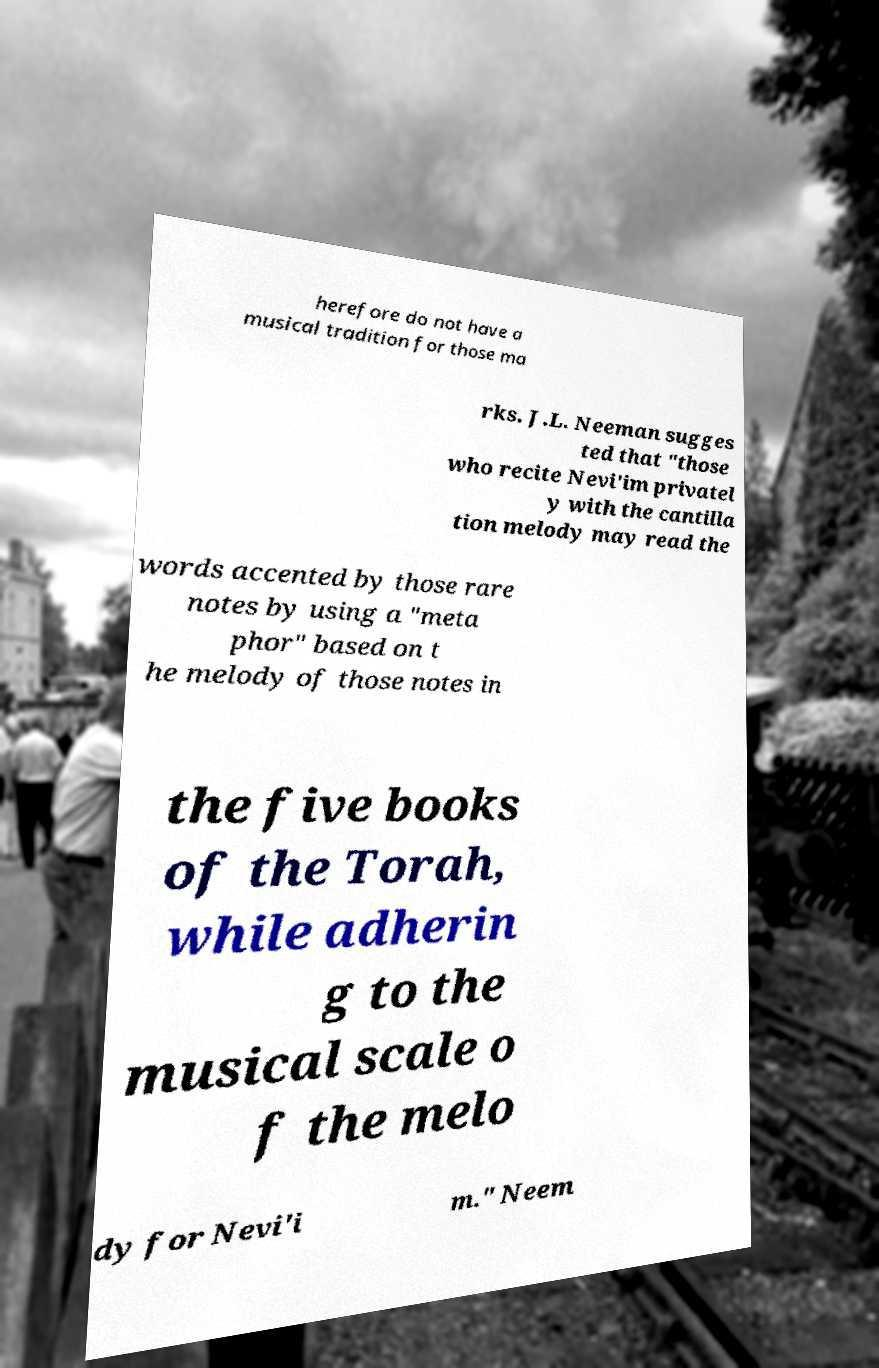What messages or text are displayed in this image? I need them in a readable, typed format. herefore do not have a musical tradition for those ma rks. J.L. Neeman sugges ted that "those who recite Nevi'im privatel y with the cantilla tion melody may read the words accented by those rare notes by using a "meta phor" based on t he melody of those notes in the five books of the Torah, while adherin g to the musical scale o f the melo dy for Nevi'i m." Neem 